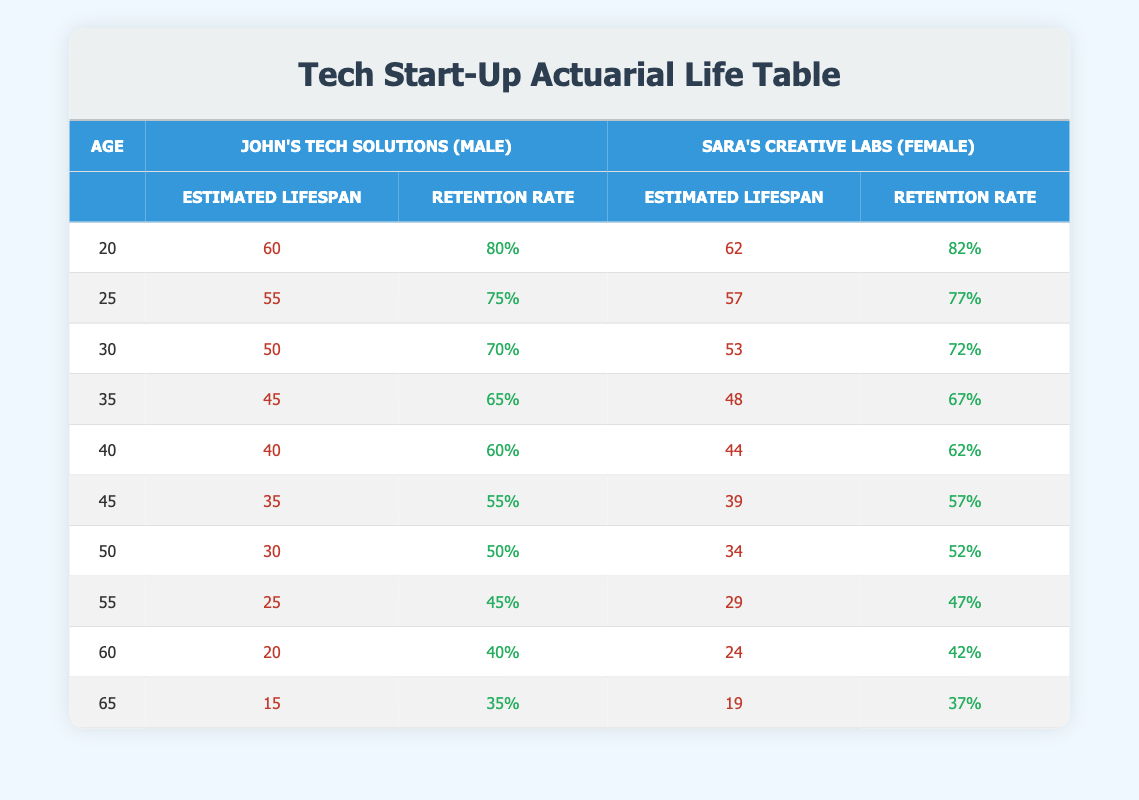What is the estimated average lifespan for male subscribers at age 40? According to the table, for male subscribers from John's Tech Solutions at age 40, the estimated average lifespan is 40 years.
Answer: 40 What is the retention rate for female subscribers at age 30? The table shows that the retention rate for female subscribers from Sara's Creative Labs at age 30 is 72%.
Answer: 72% How much longer is the estimated lifespan of female subscribers compared to male subscribers at age 50? For Sara's Creative Labs (female), the estimated lifespan at age 50 is 34 years, while for John's Tech Solutions (male), it is 30 years. The difference is 34 - 30 = 4 years.
Answer: 4 years Is the retention rate for John’s Tech Solutions higher than 50% at age 45? Looking at the table, the retention rate for John's Tech Solutions at age 45 is 55%, which is indeed higher than 50%.
Answer: Yes What is the estimated average lifespan for age 60 for both male and female subscribers combined? For male subscribers at age 60, the estimated lifespan is 20 years. For female subscribers, it is 24 years. Therefore, the combined lifespan is (20 + 24) / 2 = 22 years.
Answer: 22 years At what age does the retention rate for male subscribers fall below 40%? Reviewing the table, the retention rate for male subscribers falls below 40% at age 60 (40%) and becomes 35% at age 65, so this is the first age where it is below 40%.
Answer: 60 years What is the average estimated lifespan for both genders combined at age 35? For males at age 35, the lifespan is 45 years. For females at the same age, it is 48 years, leading to a combined average of (45 + 48) / 2 = 46.5 years.
Answer: 46.5 years What is the percentage difference in retention rates between John's Tech Solutions and Sara's Creative Labs at age 25? The retention rate for John's Tech Solutions at age 25 is 75% and for Sara's Creative Labs is 77%. The percentage difference is (77 - 75) / 75 * 100 = 2.67%.
Answer: 2.67% 